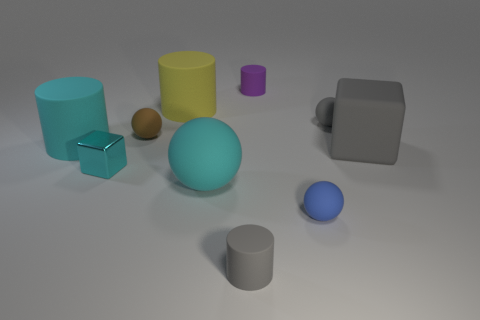Subtract all small matte balls. How many balls are left? 1 Subtract 1 cyan balls. How many objects are left? 9 Subtract all balls. How many objects are left? 6 Subtract 1 blocks. How many blocks are left? 1 Subtract all green balls. Subtract all red cylinders. How many balls are left? 4 Subtract all brown spheres. How many gray cubes are left? 1 Subtract all tiny brown things. Subtract all tiny cylinders. How many objects are left? 7 Add 1 rubber objects. How many rubber objects are left? 10 Add 6 gray rubber cubes. How many gray rubber cubes exist? 7 Subtract all brown balls. How many balls are left? 3 